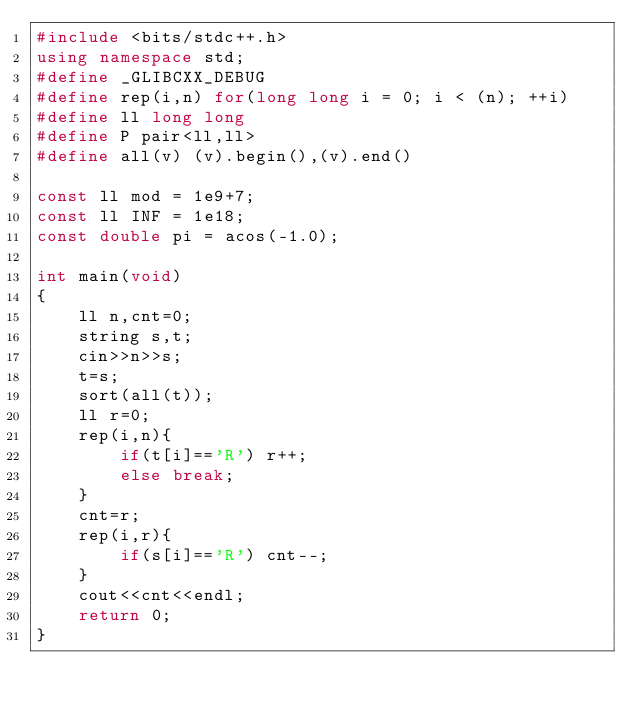<code> <loc_0><loc_0><loc_500><loc_500><_C++_>#include <bits/stdc++.h>
using namespace std;
#define _GLIBCXX_DEBUG
#define rep(i,n) for(long long i = 0; i < (n); ++i)
#define ll long long
#define P pair<ll,ll>
#define all(v) (v).begin(),(v).end()

const ll mod = 1e9+7;
const ll INF = 1e18;
const double pi = acos(-1.0);

int main(void)
{
    ll n,cnt=0;
    string s,t;
    cin>>n>>s;
    t=s;
    sort(all(t));
    ll r=0;
    rep(i,n){
        if(t[i]=='R') r++;
        else break;
    }
    cnt=r;
    rep(i,r){
        if(s[i]=='R') cnt--;
    }
    cout<<cnt<<endl;
    return 0;
}</code> 